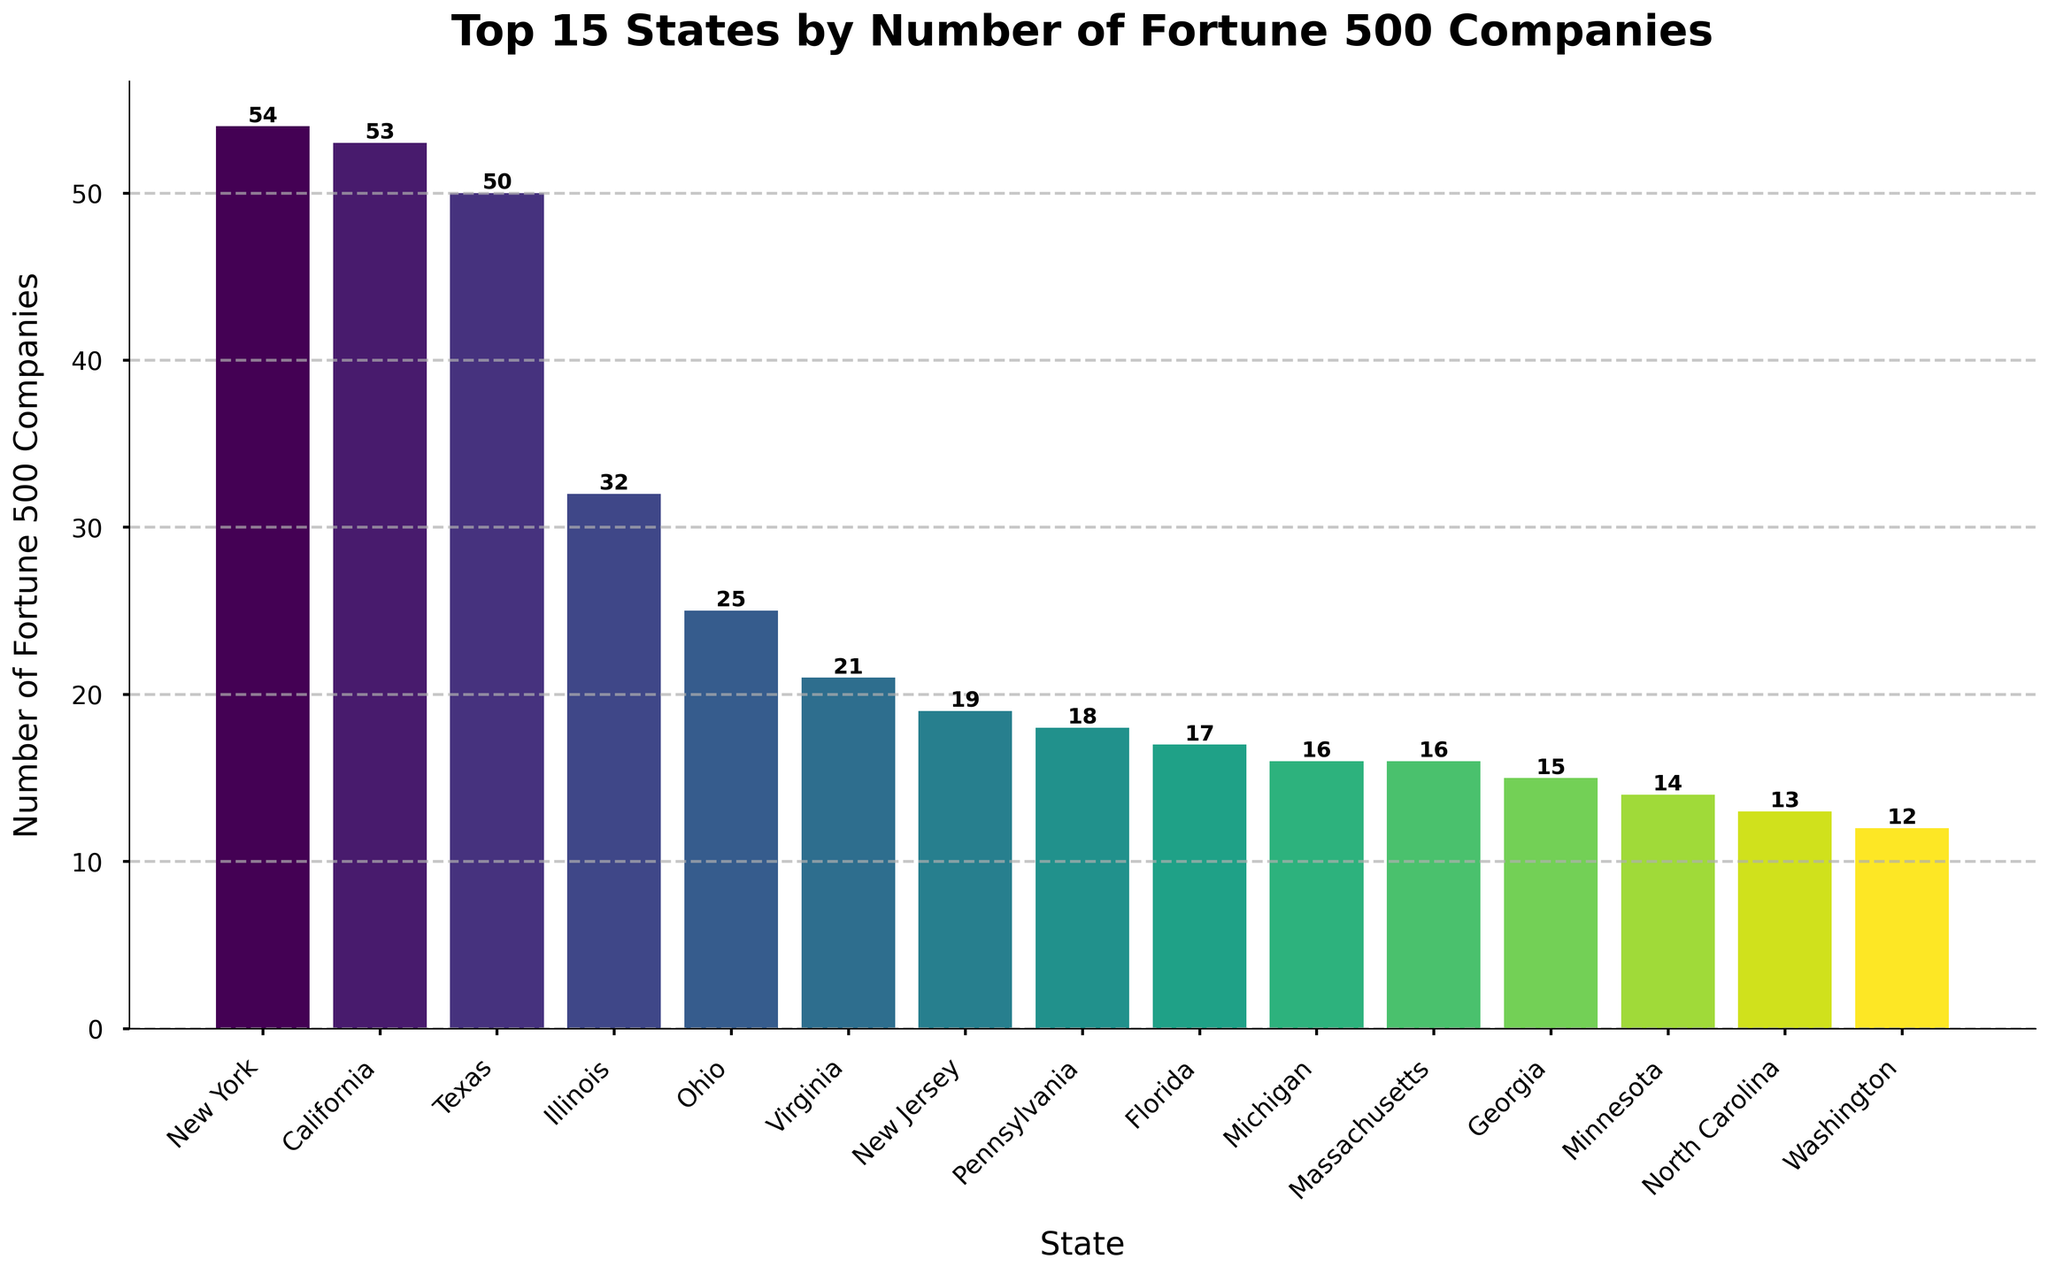How many Fortune 500 companies are in California compared to New York? First, identify the number of companies in California (53) and New York (54). Then, compare them.
Answer: New York has 1 more company than California Which state is ranked third in terms of the number of Fortune 500 companies? Look at the descending order of the states to find the state with the third-highest number of companies, which is Texas with 50 companies.
Answer: Texas How many more Fortune 500 companies does New York have than Illinois? New York has 54 companies and Illinois has 32. Subtract the number of companies in Illinois from New York's: 54 - 32 = 22.
Answer: 22 What is the total number of Fortune 500 companies in the top 5 states? Add the number of companies in the top five states: New York (54), California (53), Texas (50), Illinois (32), and Ohio (25). The total is 54 + 53 + 50 + 32 + 25 = 214.
Answer: 214 Which states have more than 20 Fortune 500 companies? Identify states with numbers higher than 20: New York (54), California (53), Texas (50), Illinois (32), Ohio (25), and Virginia (21).
Answer: New York, California, Texas, Illinois, Ohio, Virginia What is the average number of Fortune 500 companies in the top 10 states? Sum the number of companies in the top 10 states: 54 + 53 + 50 + 32 + 25 + 21 + 19 + 18 + 17 + 16 = 305. Then, divide by 10 (the number of states): 305/10 = 30.5.
Answer: 30.5 How many states in the top 15 have exactly 16 Fortune 500 companies? Locate states with exactly 16 companies within the top 15: Massachusetts and Michigan both have 16 companies. This totals to 2 states.
Answer: 2 Which state ranks higher, Virginia or New Jersey, in terms of the number of Fortune 500 companies? Identify the position of Virginia (21) and New Jersey (19). Virginia has a higher count than New Jersey.
Answer: Virginia How does the height of the bar representing Florida compare to that of Massachusetts? Observe the bars representing Florida (17 companies) and Massachusetts (16 companies). Florida's bar is slightly higher than Massachusetts's.
Answer: Florida's bar is higher What is the sum of Fortune 500 companies in the states ranked from 6th to 10th? Sum the number of companies in the states ranked 6th to 10th: Virginia (21), New Jersey (19), Pennsylvania (18), Florida (17), and Massachusetts (16). The total is 21 + 19 + 18 + 17 + 16 = 91.
Answer: 91 